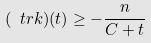Convert formula to latex. <formula><loc_0><loc_0><loc_500><loc_500>( \ t r k ) ( t ) \geq - \frac { n } { C + t }</formula> 